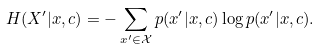Convert formula to latex. <formula><loc_0><loc_0><loc_500><loc_500>H ( X ^ { \prime } | x , c ) = - \sum _ { x ^ { \prime } \in \mathcal { X } } p ( x ^ { \prime } | x , c ) \log p ( x ^ { \prime } | x , c ) .</formula> 